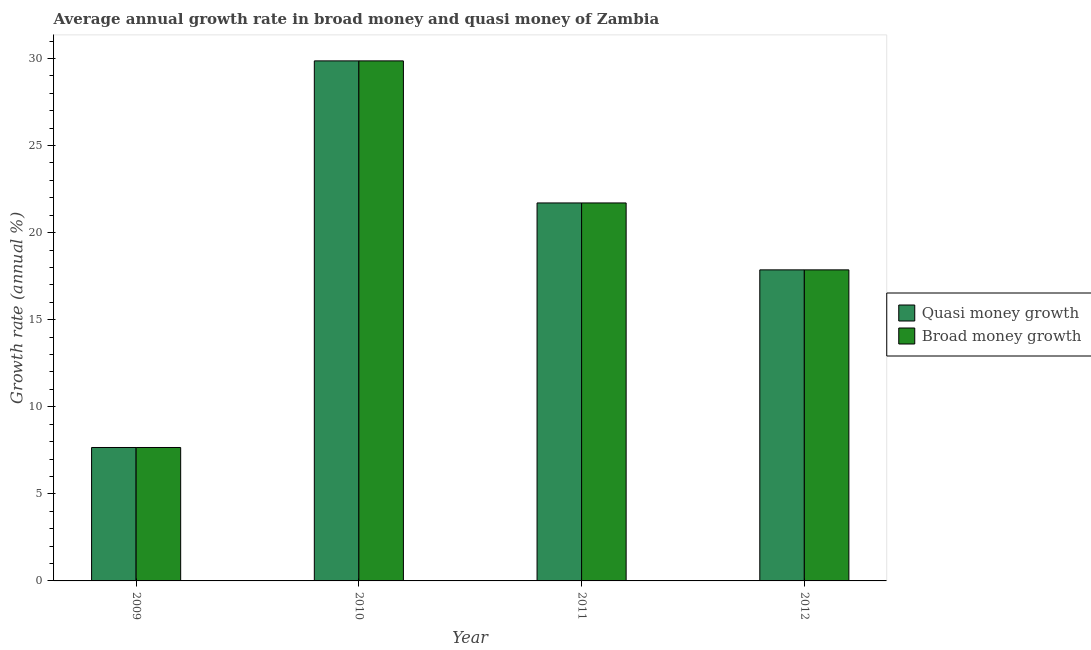Are the number of bars per tick equal to the number of legend labels?
Ensure brevity in your answer.  Yes. Are the number of bars on each tick of the X-axis equal?
Provide a short and direct response. Yes. How many bars are there on the 3rd tick from the right?
Your response must be concise. 2. What is the label of the 1st group of bars from the left?
Give a very brief answer. 2009. In how many cases, is the number of bars for a given year not equal to the number of legend labels?
Your answer should be very brief. 0. What is the annual growth rate in broad money in 2009?
Your answer should be compact. 7.66. Across all years, what is the maximum annual growth rate in quasi money?
Your answer should be very brief. 29.86. Across all years, what is the minimum annual growth rate in broad money?
Give a very brief answer. 7.66. What is the total annual growth rate in quasi money in the graph?
Your answer should be very brief. 77.08. What is the difference between the annual growth rate in broad money in 2009 and that in 2011?
Offer a very short reply. -14.04. What is the difference between the annual growth rate in quasi money in 2012 and the annual growth rate in broad money in 2011?
Your answer should be very brief. -3.84. What is the average annual growth rate in quasi money per year?
Provide a succinct answer. 19.27. In the year 2011, what is the difference between the annual growth rate in broad money and annual growth rate in quasi money?
Your response must be concise. 0. What is the ratio of the annual growth rate in broad money in 2011 to that in 2012?
Provide a succinct answer. 1.22. Is the annual growth rate in broad money in 2009 less than that in 2011?
Your answer should be very brief. Yes. Is the difference between the annual growth rate in broad money in 2011 and 2012 greater than the difference between the annual growth rate in quasi money in 2011 and 2012?
Provide a short and direct response. No. What is the difference between the highest and the second highest annual growth rate in broad money?
Your answer should be very brief. 8.16. What is the difference between the highest and the lowest annual growth rate in quasi money?
Provide a succinct answer. 22.2. What does the 2nd bar from the left in 2011 represents?
Provide a succinct answer. Broad money growth. What does the 1st bar from the right in 2010 represents?
Provide a short and direct response. Broad money growth. Are all the bars in the graph horizontal?
Give a very brief answer. No. Does the graph contain any zero values?
Your answer should be very brief. No. Where does the legend appear in the graph?
Ensure brevity in your answer.  Center right. How many legend labels are there?
Ensure brevity in your answer.  2. How are the legend labels stacked?
Make the answer very short. Vertical. What is the title of the graph?
Provide a succinct answer. Average annual growth rate in broad money and quasi money of Zambia. Does "Largest city" appear as one of the legend labels in the graph?
Your answer should be very brief. No. What is the label or title of the Y-axis?
Make the answer very short. Growth rate (annual %). What is the Growth rate (annual %) of Quasi money growth in 2009?
Provide a short and direct response. 7.66. What is the Growth rate (annual %) in Broad money growth in 2009?
Offer a terse response. 7.66. What is the Growth rate (annual %) of Quasi money growth in 2010?
Give a very brief answer. 29.86. What is the Growth rate (annual %) of Broad money growth in 2010?
Your response must be concise. 29.86. What is the Growth rate (annual %) of Quasi money growth in 2011?
Offer a very short reply. 21.7. What is the Growth rate (annual %) of Broad money growth in 2011?
Keep it short and to the point. 21.7. What is the Growth rate (annual %) in Quasi money growth in 2012?
Provide a succinct answer. 17.86. What is the Growth rate (annual %) in Broad money growth in 2012?
Offer a very short reply. 17.86. Across all years, what is the maximum Growth rate (annual %) of Quasi money growth?
Provide a short and direct response. 29.86. Across all years, what is the maximum Growth rate (annual %) of Broad money growth?
Keep it short and to the point. 29.86. Across all years, what is the minimum Growth rate (annual %) in Quasi money growth?
Your answer should be compact. 7.66. Across all years, what is the minimum Growth rate (annual %) of Broad money growth?
Offer a terse response. 7.66. What is the total Growth rate (annual %) in Quasi money growth in the graph?
Offer a terse response. 77.08. What is the total Growth rate (annual %) of Broad money growth in the graph?
Give a very brief answer. 77.08. What is the difference between the Growth rate (annual %) of Quasi money growth in 2009 and that in 2010?
Give a very brief answer. -22.2. What is the difference between the Growth rate (annual %) of Broad money growth in 2009 and that in 2010?
Ensure brevity in your answer.  -22.2. What is the difference between the Growth rate (annual %) of Quasi money growth in 2009 and that in 2011?
Give a very brief answer. -14.04. What is the difference between the Growth rate (annual %) of Broad money growth in 2009 and that in 2011?
Provide a short and direct response. -14.04. What is the difference between the Growth rate (annual %) of Quasi money growth in 2009 and that in 2012?
Ensure brevity in your answer.  -10.2. What is the difference between the Growth rate (annual %) in Broad money growth in 2009 and that in 2012?
Offer a very short reply. -10.2. What is the difference between the Growth rate (annual %) in Quasi money growth in 2010 and that in 2011?
Keep it short and to the point. 8.16. What is the difference between the Growth rate (annual %) of Broad money growth in 2010 and that in 2011?
Ensure brevity in your answer.  8.16. What is the difference between the Growth rate (annual %) of Quasi money growth in 2010 and that in 2012?
Offer a terse response. 12. What is the difference between the Growth rate (annual %) in Broad money growth in 2010 and that in 2012?
Your answer should be compact. 12. What is the difference between the Growth rate (annual %) of Quasi money growth in 2011 and that in 2012?
Make the answer very short. 3.84. What is the difference between the Growth rate (annual %) of Broad money growth in 2011 and that in 2012?
Provide a succinct answer. 3.84. What is the difference between the Growth rate (annual %) in Quasi money growth in 2009 and the Growth rate (annual %) in Broad money growth in 2010?
Keep it short and to the point. -22.2. What is the difference between the Growth rate (annual %) of Quasi money growth in 2009 and the Growth rate (annual %) of Broad money growth in 2011?
Offer a terse response. -14.04. What is the difference between the Growth rate (annual %) in Quasi money growth in 2009 and the Growth rate (annual %) in Broad money growth in 2012?
Provide a short and direct response. -10.2. What is the difference between the Growth rate (annual %) in Quasi money growth in 2010 and the Growth rate (annual %) in Broad money growth in 2011?
Make the answer very short. 8.16. What is the difference between the Growth rate (annual %) in Quasi money growth in 2010 and the Growth rate (annual %) in Broad money growth in 2012?
Your answer should be compact. 12. What is the difference between the Growth rate (annual %) in Quasi money growth in 2011 and the Growth rate (annual %) in Broad money growth in 2012?
Make the answer very short. 3.84. What is the average Growth rate (annual %) in Quasi money growth per year?
Give a very brief answer. 19.27. What is the average Growth rate (annual %) in Broad money growth per year?
Offer a terse response. 19.27. In the year 2009, what is the difference between the Growth rate (annual %) of Quasi money growth and Growth rate (annual %) of Broad money growth?
Offer a very short reply. 0. What is the ratio of the Growth rate (annual %) of Quasi money growth in 2009 to that in 2010?
Provide a succinct answer. 0.26. What is the ratio of the Growth rate (annual %) of Broad money growth in 2009 to that in 2010?
Give a very brief answer. 0.26. What is the ratio of the Growth rate (annual %) in Quasi money growth in 2009 to that in 2011?
Provide a succinct answer. 0.35. What is the ratio of the Growth rate (annual %) in Broad money growth in 2009 to that in 2011?
Your answer should be compact. 0.35. What is the ratio of the Growth rate (annual %) of Quasi money growth in 2009 to that in 2012?
Give a very brief answer. 0.43. What is the ratio of the Growth rate (annual %) of Broad money growth in 2009 to that in 2012?
Make the answer very short. 0.43. What is the ratio of the Growth rate (annual %) of Quasi money growth in 2010 to that in 2011?
Offer a terse response. 1.38. What is the ratio of the Growth rate (annual %) in Broad money growth in 2010 to that in 2011?
Offer a terse response. 1.38. What is the ratio of the Growth rate (annual %) of Quasi money growth in 2010 to that in 2012?
Your response must be concise. 1.67. What is the ratio of the Growth rate (annual %) of Broad money growth in 2010 to that in 2012?
Make the answer very short. 1.67. What is the ratio of the Growth rate (annual %) of Quasi money growth in 2011 to that in 2012?
Give a very brief answer. 1.22. What is the ratio of the Growth rate (annual %) in Broad money growth in 2011 to that in 2012?
Offer a terse response. 1.22. What is the difference between the highest and the second highest Growth rate (annual %) of Quasi money growth?
Keep it short and to the point. 8.16. What is the difference between the highest and the second highest Growth rate (annual %) in Broad money growth?
Offer a very short reply. 8.16. What is the difference between the highest and the lowest Growth rate (annual %) of Quasi money growth?
Provide a short and direct response. 22.2. What is the difference between the highest and the lowest Growth rate (annual %) in Broad money growth?
Give a very brief answer. 22.2. 